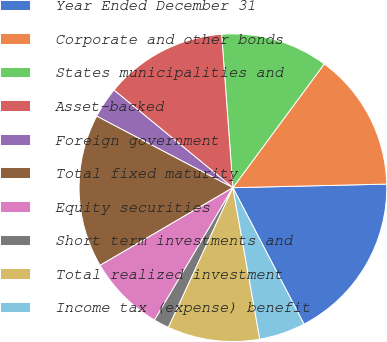<chart> <loc_0><loc_0><loc_500><loc_500><pie_chart><fcel>Year Ended December 31<fcel>Corporate and other bonds<fcel>States municipalities and<fcel>Asset-backed<fcel>Foreign government<fcel>Total fixed maturity<fcel>Equity securities<fcel>Short term investments and<fcel>Total realized investment<fcel>Income tax (expense) benefit<nl><fcel>17.73%<fcel>14.51%<fcel>11.29%<fcel>12.9%<fcel>3.24%<fcel>16.12%<fcel>8.07%<fcel>1.63%<fcel>9.68%<fcel>4.85%<nl></chart> 